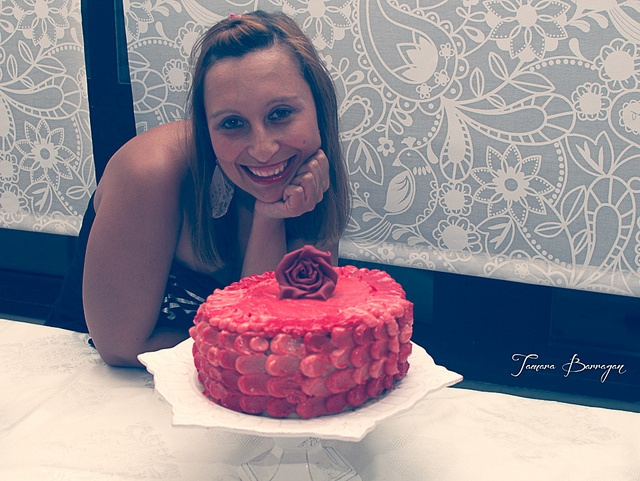Describe the objects in this image and their specific colors. I can see people in lightgray, gray, navy, and darkblue tones and cake in lightgray, salmon, brown, and purple tones in this image. 